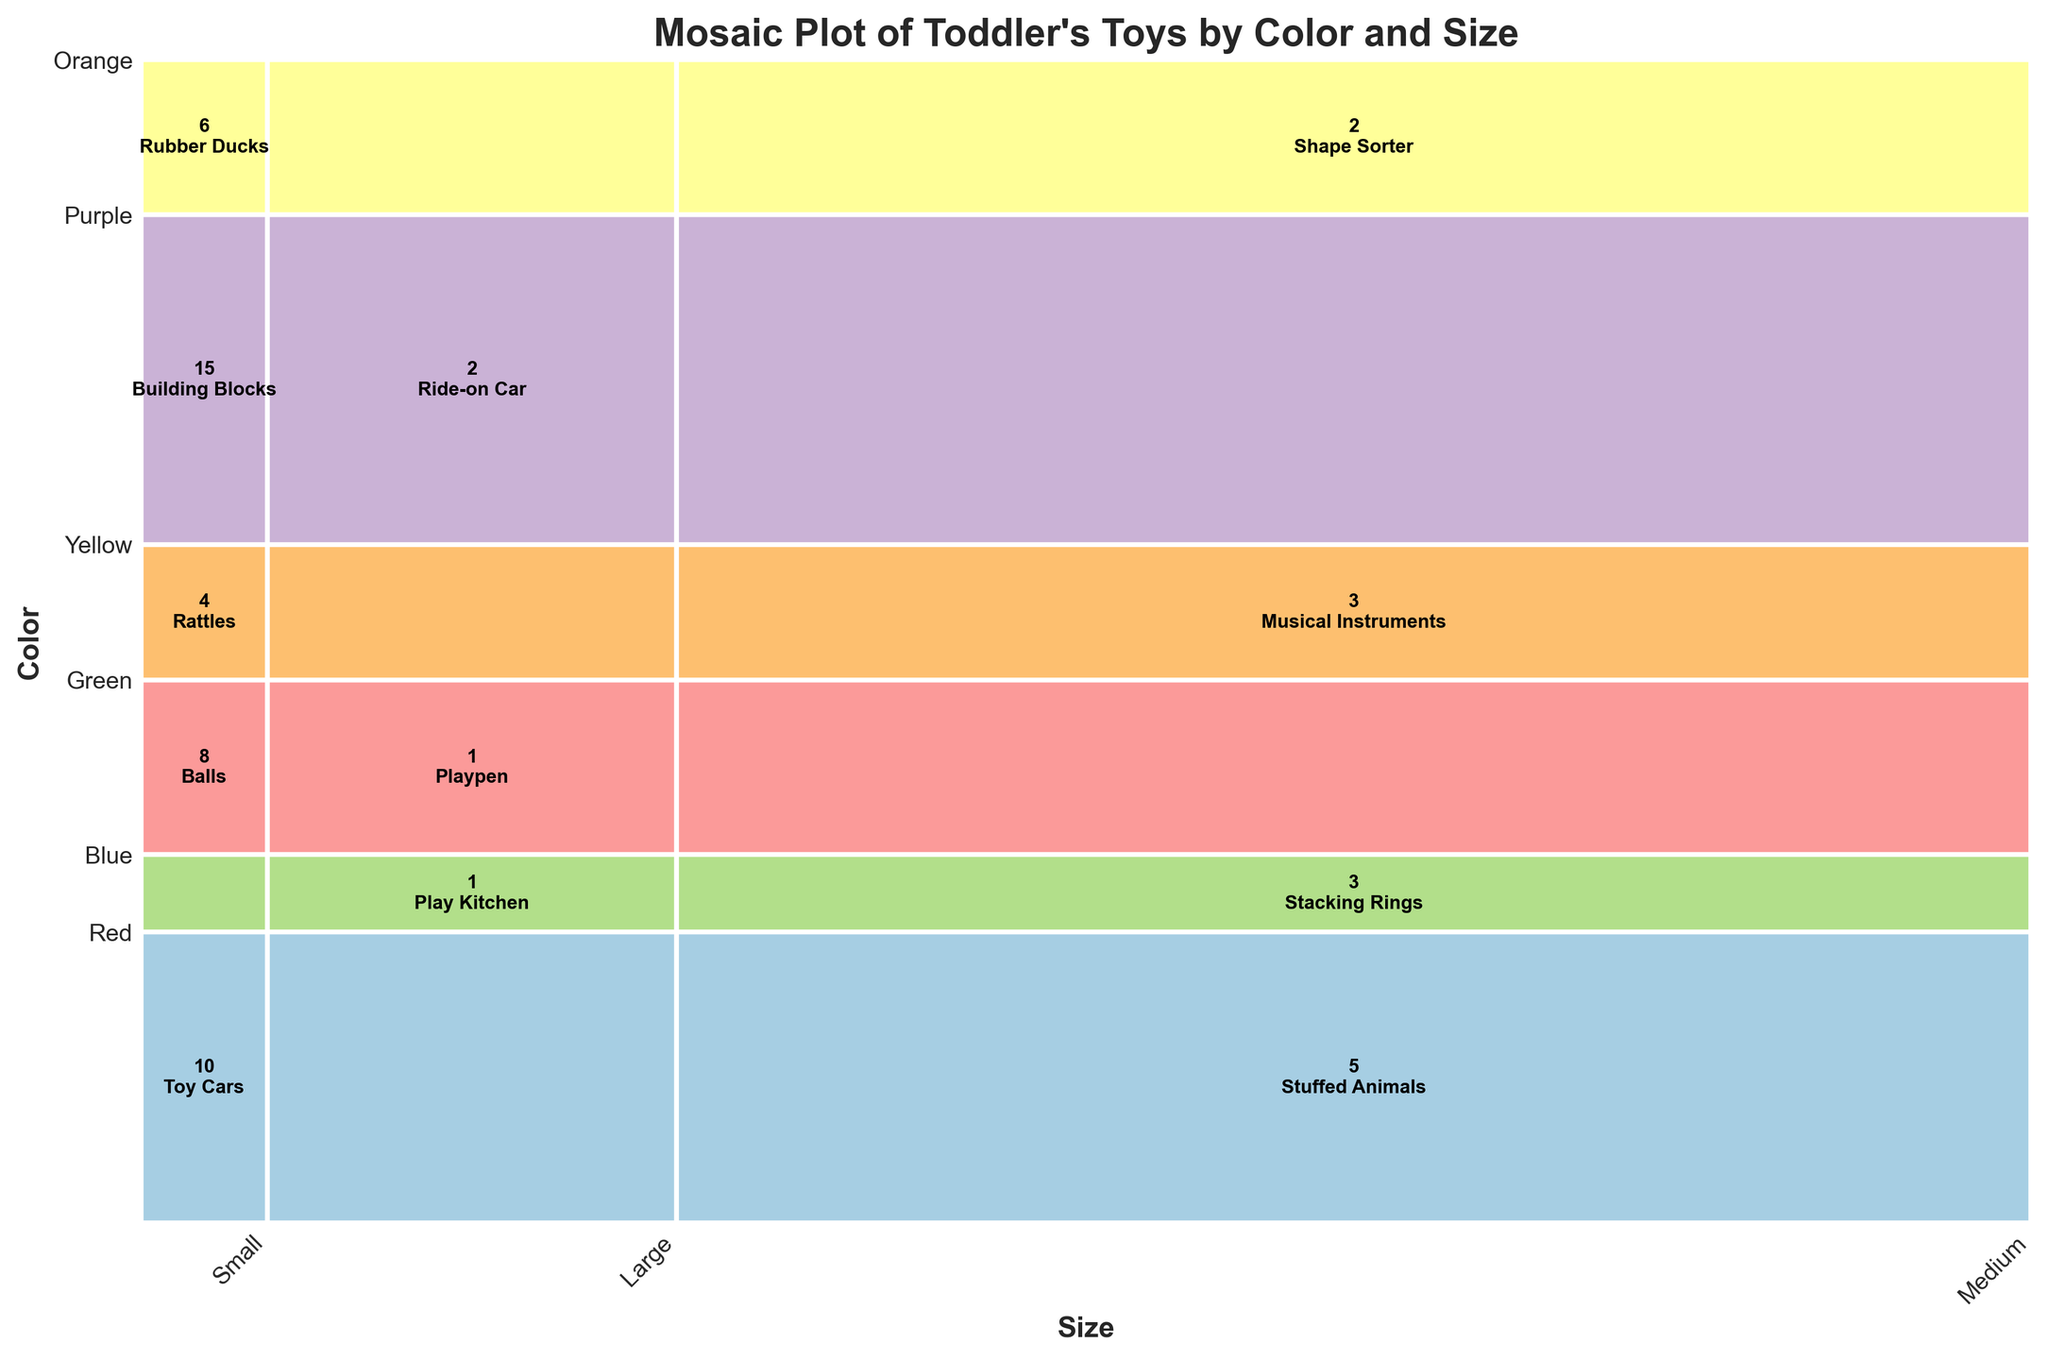What's the title of the plot? The title is usually provided at the top of the plot. In this case, it's written in bold and larger font above the chart area.
Answer: Mosaic Plot of Toddler's Toys by Color and Size What are the labels along the x-axis? The x-axis labels are located at the bottom of the plot, describing the distinct categories for 'Size', rotated slightly for better readability.
Answer: Small, Medium, Large What are the labels along the y-axis? The y-axis labels are located on the left side of the plot, indicating the different 'Color' categories of the toys.
Answer: Red, Blue, Green, Yellow, Purple, Orange Which toy category has the largest rectangle? The largest rectangle is the one with the largest area, which represents the toy category with the highest count relative to other categories. It is visually prominent in the plot.
Answer: Red, Small, Building Blocks How many small toys are there in total? Sum the counts of all rectangles in the 'Small' category along the x-axis. (Building Blocks 15 + Toy Cars 10 + Rubber Ducks 6 + Rattles 4 + Balls 8)
Answer: 43 Which color has the most toys regardless of size? Sum the heights of the rectangles within each color category along the y-axis, then compare visually.
Answer: Red How many Large toys are there in total? Sum the counts of all rectangles in the 'Large' category along the x-axis. (Ride-on Car 2 + Play Kitchen 1 + Playpen 1)
Answer: 4 How does the number of Blue toys compare between the Small and Medium size categories? Compare the areas (representing counts) of the 'Small' and 'Medium' rectangles in the Blue color category. 'Small' has Toy Cars (10), while 'Medium' has Stuffed Animals (5).
Answer: Small > Medium Which size has the fewest toys across all colors? Sum counts for each size and compare. 'Large' is visually smallest, adding Ride-on Car 2 + Play Kitchen 1 + Playpen 1.
Answer: Large What is the least popular toy category by color and size? Identify the smallest rectangle in the grid, indicating the lowest count. It is visually the smallest shaded area.
Answer: Green, Large, Play Kitchen Which medium-sized toy has the highest count? Compare the areas (representing counts) of all rectangles in the 'Medium' category (across the x-axis). The tallest among them shows the highest count.
Answer: Stuffed Animals (Blue, Medium) 